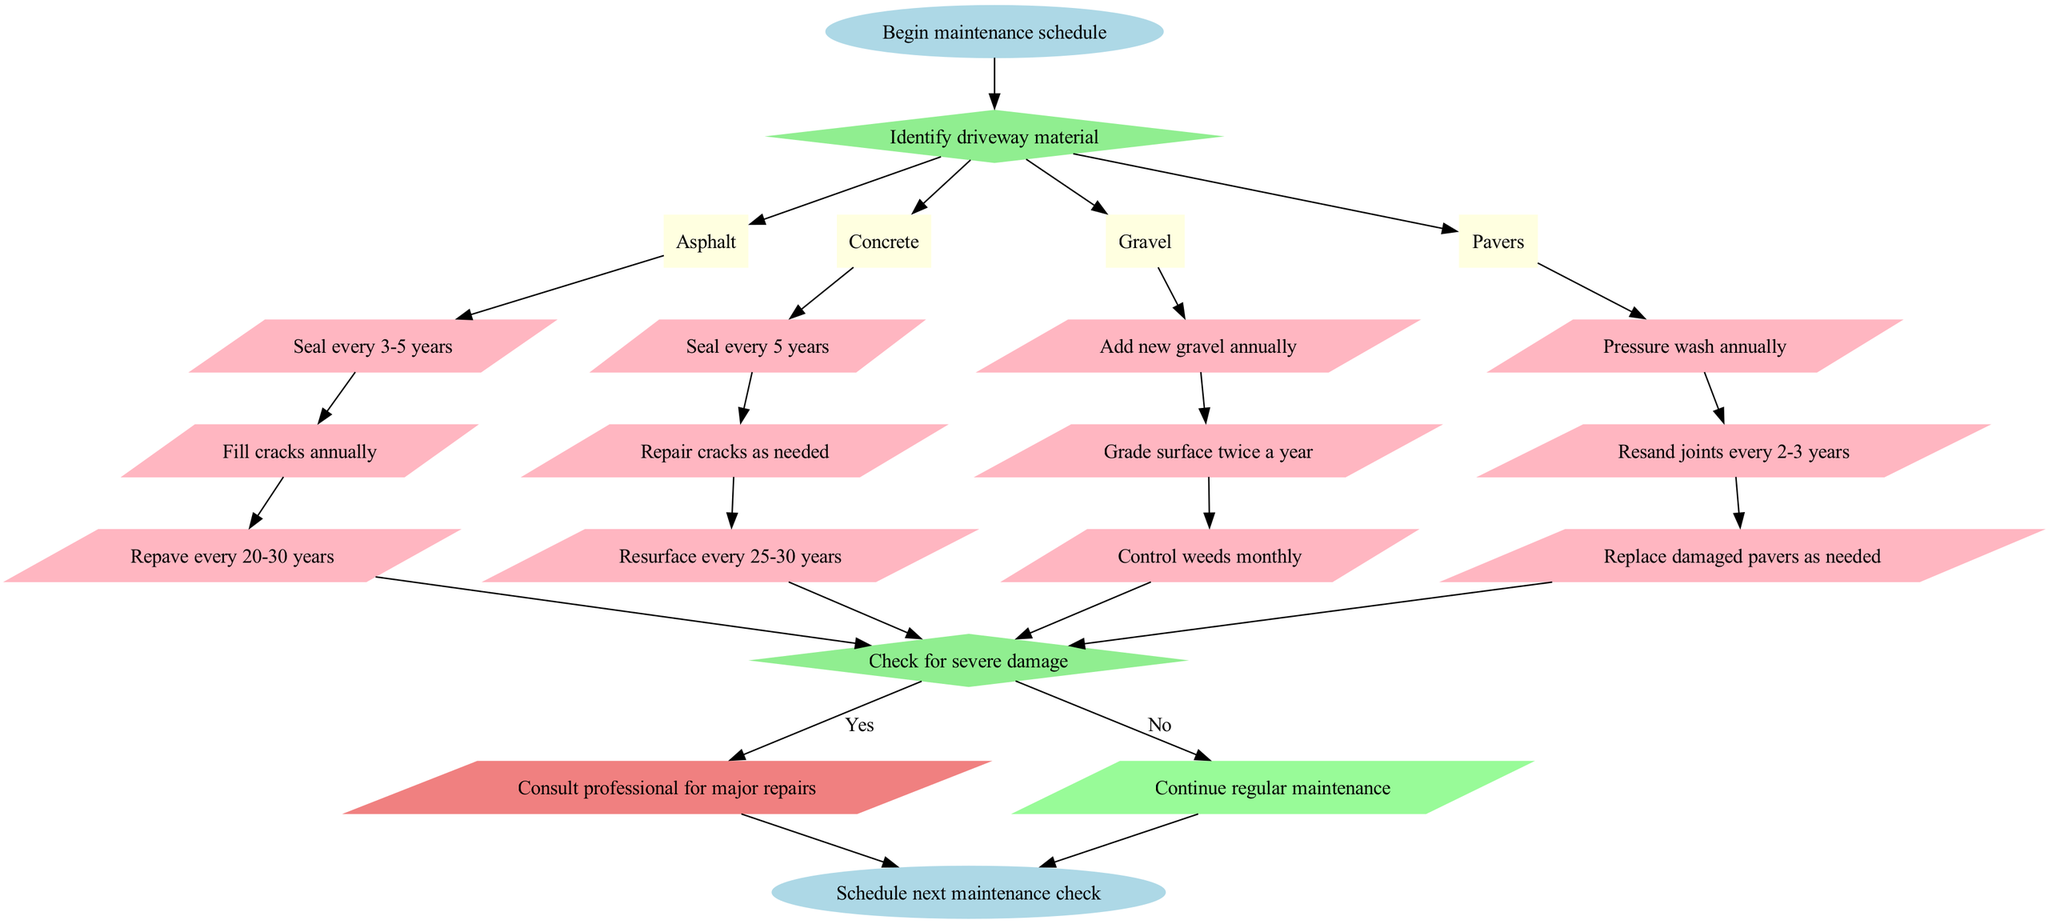What is the starting point of the maintenance schedule? The diagram indicates that the starting point is the node labeled 'Begin maintenance schedule'. This signifies where the maintenance workflow initiates.
Answer: Begin maintenance schedule How many driveway materials are identified in the diagram? The diagram lists four different materials: Asphalt, Concrete, Gravel, and Pavers. Counting these, there are a total of four materials identified.
Answer: 4 What maintenance action is recommended for asphalt driveways? The diagram specifies multiple actions for asphalt, the first of which is 'Seal every 3-5 years'. This is a crucial maintenance step to extend the driveway's lifespan.
Answer: Seal every 3-5 years What action should be taken if severe damage is detected? The diagram indicates that if severe damage is detected, the next step is 'Consult professional for major repairs'. This leads to obtaining expert assistance for significant issues.
Answer: Consult professional for major repairs In what scenario should regular maintenance continue? The diagram specifies that if there is no severe damage detected, 'Continue regular maintenance' is the next step. This shows that ongoing maintenance is essential when no major issues are present.
Answer: Continue regular maintenance Which material requires grading of the surface? Among the listed actions for the materials, 'Grade surface twice a year' is specifically mentioned for Gravel driveways. This action is necessary to maintain the surface quality effectively.
Answer: Gravel What happens at the end of the maintenance process? The final node in the diagram states 'Schedule next maintenance check'. This indicates that at the end of the process, another check should be planned to ensure ongoing care.
Answer: Schedule next maintenance check How often should pavers be pressure washed? According to the actions outlined for Pavers, the recommended maintenance action is to 'Pressure wash annually', indicating a yearly obligation for maintenance.
Answer: Pressure wash annually What action should be performed on concrete if cracks appear? The diagram indicates that if cracks appear in Concrete, the action to take is to 'Repair cracks as needed'. This highlights the importance of responding to visible damage to maintain integrity.
Answer: Repair cracks as needed What decision follows after completing maintenance actions for each material? The decision that follows is to 'Check for severe damage', which signifies a crucial point to assess the condition after completing the regular maintenance tasks.
Answer: Check for severe damage 